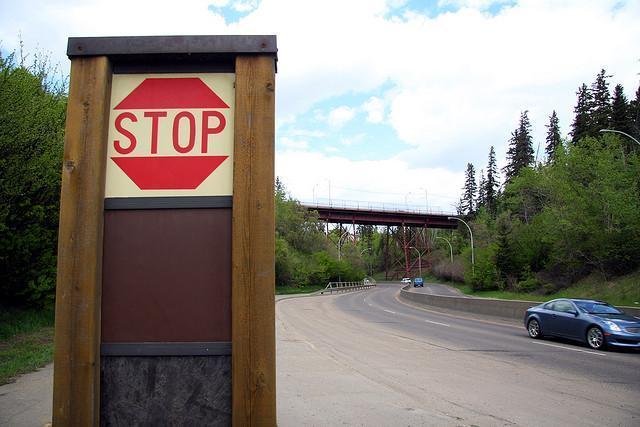How many lamp posts are there?
Give a very brief answer. 4. How many sandwiches with tomato are there?
Give a very brief answer. 0. 